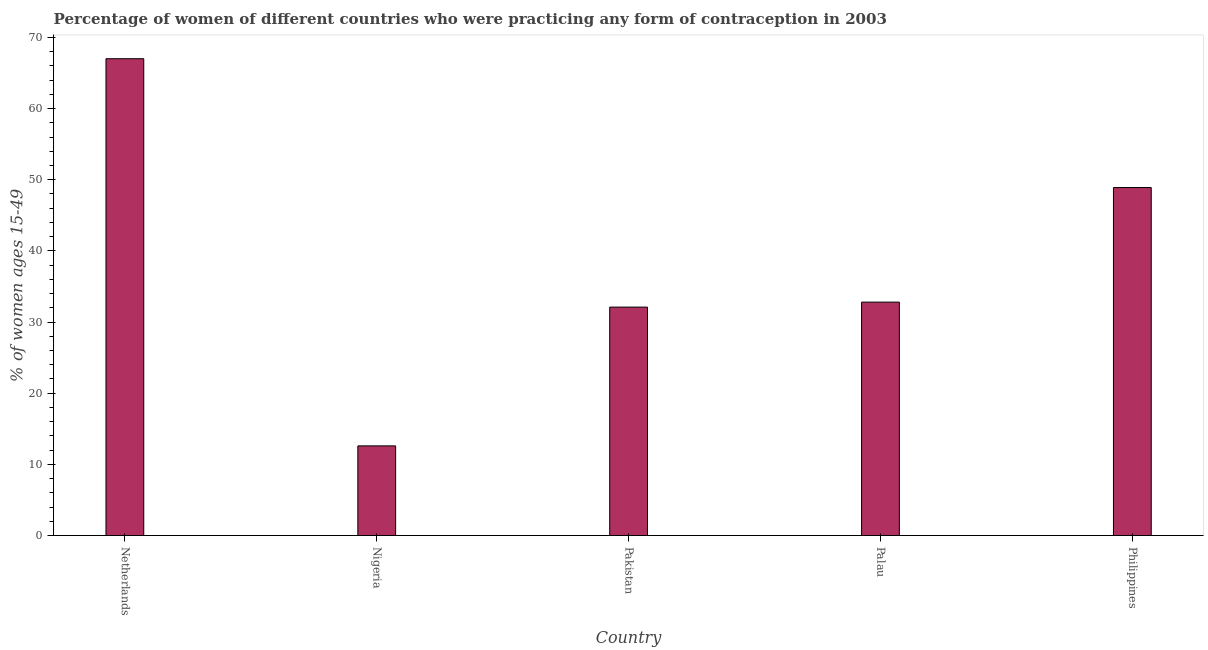What is the title of the graph?
Offer a very short reply. Percentage of women of different countries who were practicing any form of contraception in 2003. What is the label or title of the X-axis?
Keep it short and to the point. Country. What is the label or title of the Y-axis?
Your answer should be very brief. % of women ages 15-49. Across all countries, what is the maximum contraceptive prevalence?
Ensure brevity in your answer.  67. In which country was the contraceptive prevalence minimum?
Offer a terse response. Nigeria. What is the sum of the contraceptive prevalence?
Give a very brief answer. 193.4. What is the difference between the contraceptive prevalence in Palau and Philippines?
Provide a short and direct response. -16.1. What is the average contraceptive prevalence per country?
Your response must be concise. 38.68. What is the median contraceptive prevalence?
Your answer should be very brief. 32.8. In how many countries, is the contraceptive prevalence greater than 20 %?
Offer a very short reply. 4. What is the ratio of the contraceptive prevalence in Netherlands to that in Palau?
Provide a short and direct response. 2.04. Is the difference between the contraceptive prevalence in Netherlands and Pakistan greater than the difference between any two countries?
Offer a terse response. No. What is the difference between the highest and the lowest contraceptive prevalence?
Offer a terse response. 54.4. In how many countries, is the contraceptive prevalence greater than the average contraceptive prevalence taken over all countries?
Your answer should be compact. 2. How many countries are there in the graph?
Your answer should be very brief. 5. What is the difference between two consecutive major ticks on the Y-axis?
Make the answer very short. 10. Are the values on the major ticks of Y-axis written in scientific E-notation?
Keep it short and to the point. No. What is the % of women ages 15-49 in Pakistan?
Provide a succinct answer. 32.1. What is the % of women ages 15-49 in Palau?
Keep it short and to the point. 32.8. What is the % of women ages 15-49 of Philippines?
Offer a very short reply. 48.9. What is the difference between the % of women ages 15-49 in Netherlands and Nigeria?
Ensure brevity in your answer.  54.4. What is the difference between the % of women ages 15-49 in Netherlands and Pakistan?
Ensure brevity in your answer.  34.9. What is the difference between the % of women ages 15-49 in Netherlands and Palau?
Your answer should be very brief. 34.2. What is the difference between the % of women ages 15-49 in Netherlands and Philippines?
Your response must be concise. 18.1. What is the difference between the % of women ages 15-49 in Nigeria and Pakistan?
Offer a very short reply. -19.5. What is the difference between the % of women ages 15-49 in Nigeria and Palau?
Your answer should be compact. -20.2. What is the difference between the % of women ages 15-49 in Nigeria and Philippines?
Make the answer very short. -36.3. What is the difference between the % of women ages 15-49 in Pakistan and Philippines?
Your response must be concise. -16.8. What is the difference between the % of women ages 15-49 in Palau and Philippines?
Give a very brief answer. -16.1. What is the ratio of the % of women ages 15-49 in Netherlands to that in Nigeria?
Give a very brief answer. 5.32. What is the ratio of the % of women ages 15-49 in Netherlands to that in Pakistan?
Keep it short and to the point. 2.09. What is the ratio of the % of women ages 15-49 in Netherlands to that in Palau?
Your answer should be compact. 2.04. What is the ratio of the % of women ages 15-49 in Netherlands to that in Philippines?
Provide a short and direct response. 1.37. What is the ratio of the % of women ages 15-49 in Nigeria to that in Pakistan?
Make the answer very short. 0.39. What is the ratio of the % of women ages 15-49 in Nigeria to that in Palau?
Provide a succinct answer. 0.38. What is the ratio of the % of women ages 15-49 in Nigeria to that in Philippines?
Provide a short and direct response. 0.26. What is the ratio of the % of women ages 15-49 in Pakistan to that in Philippines?
Provide a succinct answer. 0.66. What is the ratio of the % of women ages 15-49 in Palau to that in Philippines?
Offer a very short reply. 0.67. 